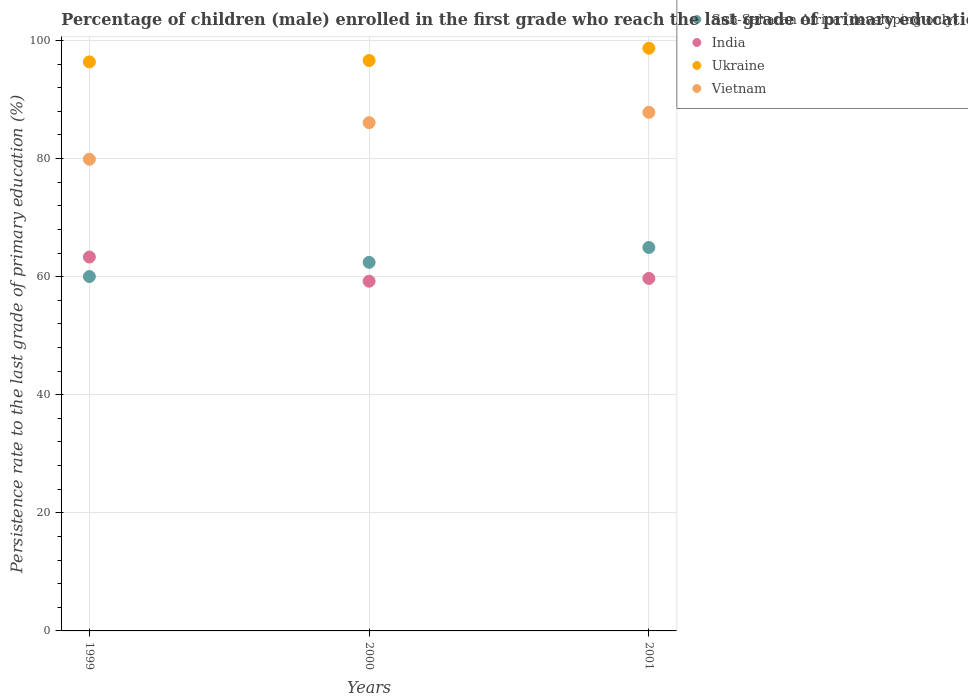How many different coloured dotlines are there?
Offer a very short reply. 4. Is the number of dotlines equal to the number of legend labels?
Your answer should be compact. Yes. What is the persistence rate of children in Ukraine in 1999?
Give a very brief answer. 96.38. Across all years, what is the maximum persistence rate of children in Ukraine?
Your answer should be very brief. 98.69. Across all years, what is the minimum persistence rate of children in Vietnam?
Your answer should be very brief. 79.89. What is the total persistence rate of children in India in the graph?
Your answer should be very brief. 182.26. What is the difference between the persistence rate of children in Sub-Saharan Africa (developing only) in 2000 and that in 2001?
Give a very brief answer. -2.52. What is the difference between the persistence rate of children in India in 1999 and the persistence rate of children in Vietnam in 2001?
Your response must be concise. -24.51. What is the average persistence rate of children in Vietnam per year?
Ensure brevity in your answer.  84.61. In the year 1999, what is the difference between the persistence rate of children in India and persistence rate of children in Vietnam?
Offer a very short reply. -16.57. In how many years, is the persistence rate of children in Vietnam greater than 80 %?
Ensure brevity in your answer.  2. What is the ratio of the persistence rate of children in Ukraine in 1999 to that in 2000?
Offer a very short reply. 1. Is the difference between the persistence rate of children in India in 1999 and 2000 greater than the difference between the persistence rate of children in Vietnam in 1999 and 2000?
Give a very brief answer. Yes. What is the difference between the highest and the second highest persistence rate of children in Sub-Saharan Africa (developing only)?
Offer a very short reply. 2.52. What is the difference between the highest and the lowest persistence rate of children in Ukraine?
Offer a very short reply. 2.32. In how many years, is the persistence rate of children in Vietnam greater than the average persistence rate of children in Vietnam taken over all years?
Ensure brevity in your answer.  2. Is the sum of the persistence rate of children in Ukraine in 1999 and 2001 greater than the maximum persistence rate of children in India across all years?
Provide a short and direct response. Yes. Is it the case that in every year, the sum of the persistence rate of children in Vietnam and persistence rate of children in India  is greater than the sum of persistence rate of children in Sub-Saharan Africa (developing only) and persistence rate of children in Ukraine?
Your answer should be very brief. No. Is the persistence rate of children in Vietnam strictly greater than the persistence rate of children in India over the years?
Offer a terse response. Yes. How many years are there in the graph?
Make the answer very short. 3. What is the difference between two consecutive major ticks on the Y-axis?
Give a very brief answer. 20. Where does the legend appear in the graph?
Offer a very short reply. Top right. How many legend labels are there?
Offer a very short reply. 4. How are the legend labels stacked?
Your answer should be very brief. Vertical. What is the title of the graph?
Your response must be concise. Percentage of children (male) enrolled in the first grade who reach the last grade of primary education. Does "Benin" appear as one of the legend labels in the graph?
Provide a short and direct response. No. What is the label or title of the Y-axis?
Ensure brevity in your answer.  Persistence rate to the last grade of primary education (%). What is the Persistence rate to the last grade of primary education (%) of Sub-Saharan Africa (developing only) in 1999?
Offer a terse response. 60.02. What is the Persistence rate to the last grade of primary education (%) in India in 1999?
Make the answer very short. 63.33. What is the Persistence rate to the last grade of primary education (%) in Ukraine in 1999?
Your answer should be compact. 96.38. What is the Persistence rate to the last grade of primary education (%) in Vietnam in 1999?
Your answer should be compact. 79.89. What is the Persistence rate to the last grade of primary education (%) of Sub-Saharan Africa (developing only) in 2000?
Your answer should be compact. 62.43. What is the Persistence rate to the last grade of primary education (%) in India in 2000?
Offer a very short reply. 59.23. What is the Persistence rate to the last grade of primary education (%) of Ukraine in 2000?
Ensure brevity in your answer.  96.61. What is the Persistence rate to the last grade of primary education (%) of Vietnam in 2000?
Provide a short and direct response. 86.09. What is the Persistence rate to the last grade of primary education (%) in Sub-Saharan Africa (developing only) in 2001?
Provide a short and direct response. 64.95. What is the Persistence rate to the last grade of primary education (%) of India in 2001?
Offer a very short reply. 59.71. What is the Persistence rate to the last grade of primary education (%) in Ukraine in 2001?
Provide a succinct answer. 98.69. What is the Persistence rate to the last grade of primary education (%) in Vietnam in 2001?
Keep it short and to the point. 87.84. Across all years, what is the maximum Persistence rate to the last grade of primary education (%) in Sub-Saharan Africa (developing only)?
Your response must be concise. 64.95. Across all years, what is the maximum Persistence rate to the last grade of primary education (%) of India?
Offer a very short reply. 63.33. Across all years, what is the maximum Persistence rate to the last grade of primary education (%) in Ukraine?
Ensure brevity in your answer.  98.69. Across all years, what is the maximum Persistence rate to the last grade of primary education (%) in Vietnam?
Keep it short and to the point. 87.84. Across all years, what is the minimum Persistence rate to the last grade of primary education (%) in Sub-Saharan Africa (developing only)?
Ensure brevity in your answer.  60.02. Across all years, what is the minimum Persistence rate to the last grade of primary education (%) of India?
Your response must be concise. 59.23. Across all years, what is the minimum Persistence rate to the last grade of primary education (%) in Ukraine?
Provide a short and direct response. 96.38. Across all years, what is the minimum Persistence rate to the last grade of primary education (%) of Vietnam?
Offer a terse response. 79.89. What is the total Persistence rate to the last grade of primary education (%) of Sub-Saharan Africa (developing only) in the graph?
Give a very brief answer. 187.4. What is the total Persistence rate to the last grade of primary education (%) in India in the graph?
Offer a terse response. 182.26. What is the total Persistence rate to the last grade of primary education (%) of Ukraine in the graph?
Keep it short and to the point. 291.69. What is the total Persistence rate to the last grade of primary education (%) in Vietnam in the graph?
Offer a terse response. 253.82. What is the difference between the Persistence rate to the last grade of primary education (%) in Sub-Saharan Africa (developing only) in 1999 and that in 2000?
Your answer should be compact. -2.4. What is the difference between the Persistence rate to the last grade of primary education (%) in India in 1999 and that in 2000?
Provide a succinct answer. 4.09. What is the difference between the Persistence rate to the last grade of primary education (%) of Ukraine in 1999 and that in 2000?
Offer a terse response. -0.24. What is the difference between the Persistence rate to the last grade of primary education (%) in Vietnam in 1999 and that in 2000?
Offer a terse response. -6.2. What is the difference between the Persistence rate to the last grade of primary education (%) of Sub-Saharan Africa (developing only) in 1999 and that in 2001?
Keep it short and to the point. -4.92. What is the difference between the Persistence rate to the last grade of primary education (%) of India in 1999 and that in 2001?
Keep it short and to the point. 3.62. What is the difference between the Persistence rate to the last grade of primary education (%) in Ukraine in 1999 and that in 2001?
Keep it short and to the point. -2.32. What is the difference between the Persistence rate to the last grade of primary education (%) of Vietnam in 1999 and that in 2001?
Keep it short and to the point. -7.94. What is the difference between the Persistence rate to the last grade of primary education (%) in Sub-Saharan Africa (developing only) in 2000 and that in 2001?
Give a very brief answer. -2.52. What is the difference between the Persistence rate to the last grade of primary education (%) of India in 2000 and that in 2001?
Ensure brevity in your answer.  -0.47. What is the difference between the Persistence rate to the last grade of primary education (%) of Ukraine in 2000 and that in 2001?
Provide a short and direct response. -2.08. What is the difference between the Persistence rate to the last grade of primary education (%) in Vietnam in 2000 and that in 2001?
Your answer should be very brief. -1.75. What is the difference between the Persistence rate to the last grade of primary education (%) in Sub-Saharan Africa (developing only) in 1999 and the Persistence rate to the last grade of primary education (%) in India in 2000?
Offer a terse response. 0.79. What is the difference between the Persistence rate to the last grade of primary education (%) in Sub-Saharan Africa (developing only) in 1999 and the Persistence rate to the last grade of primary education (%) in Ukraine in 2000?
Provide a short and direct response. -36.59. What is the difference between the Persistence rate to the last grade of primary education (%) in Sub-Saharan Africa (developing only) in 1999 and the Persistence rate to the last grade of primary education (%) in Vietnam in 2000?
Your response must be concise. -26.07. What is the difference between the Persistence rate to the last grade of primary education (%) in India in 1999 and the Persistence rate to the last grade of primary education (%) in Ukraine in 2000?
Keep it short and to the point. -33.29. What is the difference between the Persistence rate to the last grade of primary education (%) of India in 1999 and the Persistence rate to the last grade of primary education (%) of Vietnam in 2000?
Give a very brief answer. -22.77. What is the difference between the Persistence rate to the last grade of primary education (%) in Ukraine in 1999 and the Persistence rate to the last grade of primary education (%) in Vietnam in 2000?
Provide a succinct answer. 10.28. What is the difference between the Persistence rate to the last grade of primary education (%) of Sub-Saharan Africa (developing only) in 1999 and the Persistence rate to the last grade of primary education (%) of India in 2001?
Provide a short and direct response. 0.32. What is the difference between the Persistence rate to the last grade of primary education (%) in Sub-Saharan Africa (developing only) in 1999 and the Persistence rate to the last grade of primary education (%) in Ukraine in 2001?
Give a very brief answer. -38.67. What is the difference between the Persistence rate to the last grade of primary education (%) of Sub-Saharan Africa (developing only) in 1999 and the Persistence rate to the last grade of primary education (%) of Vietnam in 2001?
Provide a succinct answer. -27.81. What is the difference between the Persistence rate to the last grade of primary education (%) in India in 1999 and the Persistence rate to the last grade of primary education (%) in Ukraine in 2001?
Ensure brevity in your answer.  -35.37. What is the difference between the Persistence rate to the last grade of primary education (%) of India in 1999 and the Persistence rate to the last grade of primary education (%) of Vietnam in 2001?
Make the answer very short. -24.51. What is the difference between the Persistence rate to the last grade of primary education (%) in Ukraine in 1999 and the Persistence rate to the last grade of primary education (%) in Vietnam in 2001?
Offer a terse response. 8.54. What is the difference between the Persistence rate to the last grade of primary education (%) in Sub-Saharan Africa (developing only) in 2000 and the Persistence rate to the last grade of primary education (%) in India in 2001?
Give a very brief answer. 2.72. What is the difference between the Persistence rate to the last grade of primary education (%) in Sub-Saharan Africa (developing only) in 2000 and the Persistence rate to the last grade of primary education (%) in Ukraine in 2001?
Offer a very short reply. -36.27. What is the difference between the Persistence rate to the last grade of primary education (%) of Sub-Saharan Africa (developing only) in 2000 and the Persistence rate to the last grade of primary education (%) of Vietnam in 2001?
Ensure brevity in your answer.  -25.41. What is the difference between the Persistence rate to the last grade of primary education (%) of India in 2000 and the Persistence rate to the last grade of primary education (%) of Ukraine in 2001?
Offer a terse response. -39.46. What is the difference between the Persistence rate to the last grade of primary education (%) in India in 2000 and the Persistence rate to the last grade of primary education (%) in Vietnam in 2001?
Provide a short and direct response. -28.61. What is the difference between the Persistence rate to the last grade of primary education (%) of Ukraine in 2000 and the Persistence rate to the last grade of primary education (%) of Vietnam in 2001?
Keep it short and to the point. 8.78. What is the average Persistence rate to the last grade of primary education (%) in Sub-Saharan Africa (developing only) per year?
Offer a very short reply. 62.47. What is the average Persistence rate to the last grade of primary education (%) in India per year?
Provide a succinct answer. 60.75. What is the average Persistence rate to the last grade of primary education (%) of Ukraine per year?
Provide a succinct answer. 97.23. What is the average Persistence rate to the last grade of primary education (%) of Vietnam per year?
Offer a very short reply. 84.61. In the year 1999, what is the difference between the Persistence rate to the last grade of primary education (%) of Sub-Saharan Africa (developing only) and Persistence rate to the last grade of primary education (%) of India?
Make the answer very short. -3.3. In the year 1999, what is the difference between the Persistence rate to the last grade of primary education (%) of Sub-Saharan Africa (developing only) and Persistence rate to the last grade of primary education (%) of Ukraine?
Offer a terse response. -36.35. In the year 1999, what is the difference between the Persistence rate to the last grade of primary education (%) of Sub-Saharan Africa (developing only) and Persistence rate to the last grade of primary education (%) of Vietnam?
Keep it short and to the point. -19.87. In the year 1999, what is the difference between the Persistence rate to the last grade of primary education (%) of India and Persistence rate to the last grade of primary education (%) of Ukraine?
Ensure brevity in your answer.  -33.05. In the year 1999, what is the difference between the Persistence rate to the last grade of primary education (%) of India and Persistence rate to the last grade of primary education (%) of Vietnam?
Keep it short and to the point. -16.57. In the year 1999, what is the difference between the Persistence rate to the last grade of primary education (%) in Ukraine and Persistence rate to the last grade of primary education (%) in Vietnam?
Offer a terse response. 16.48. In the year 2000, what is the difference between the Persistence rate to the last grade of primary education (%) in Sub-Saharan Africa (developing only) and Persistence rate to the last grade of primary education (%) in India?
Provide a short and direct response. 3.2. In the year 2000, what is the difference between the Persistence rate to the last grade of primary education (%) of Sub-Saharan Africa (developing only) and Persistence rate to the last grade of primary education (%) of Ukraine?
Your answer should be compact. -34.19. In the year 2000, what is the difference between the Persistence rate to the last grade of primary education (%) of Sub-Saharan Africa (developing only) and Persistence rate to the last grade of primary education (%) of Vietnam?
Make the answer very short. -23.66. In the year 2000, what is the difference between the Persistence rate to the last grade of primary education (%) of India and Persistence rate to the last grade of primary education (%) of Ukraine?
Ensure brevity in your answer.  -37.38. In the year 2000, what is the difference between the Persistence rate to the last grade of primary education (%) of India and Persistence rate to the last grade of primary education (%) of Vietnam?
Your answer should be compact. -26.86. In the year 2000, what is the difference between the Persistence rate to the last grade of primary education (%) in Ukraine and Persistence rate to the last grade of primary education (%) in Vietnam?
Provide a succinct answer. 10.52. In the year 2001, what is the difference between the Persistence rate to the last grade of primary education (%) of Sub-Saharan Africa (developing only) and Persistence rate to the last grade of primary education (%) of India?
Your answer should be compact. 5.24. In the year 2001, what is the difference between the Persistence rate to the last grade of primary education (%) of Sub-Saharan Africa (developing only) and Persistence rate to the last grade of primary education (%) of Ukraine?
Provide a short and direct response. -33.75. In the year 2001, what is the difference between the Persistence rate to the last grade of primary education (%) of Sub-Saharan Africa (developing only) and Persistence rate to the last grade of primary education (%) of Vietnam?
Provide a short and direct response. -22.89. In the year 2001, what is the difference between the Persistence rate to the last grade of primary education (%) of India and Persistence rate to the last grade of primary education (%) of Ukraine?
Your answer should be compact. -38.99. In the year 2001, what is the difference between the Persistence rate to the last grade of primary education (%) of India and Persistence rate to the last grade of primary education (%) of Vietnam?
Give a very brief answer. -28.13. In the year 2001, what is the difference between the Persistence rate to the last grade of primary education (%) of Ukraine and Persistence rate to the last grade of primary education (%) of Vietnam?
Ensure brevity in your answer.  10.86. What is the ratio of the Persistence rate to the last grade of primary education (%) in Sub-Saharan Africa (developing only) in 1999 to that in 2000?
Offer a very short reply. 0.96. What is the ratio of the Persistence rate to the last grade of primary education (%) in India in 1999 to that in 2000?
Give a very brief answer. 1.07. What is the ratio of the Persistence rate to the last grade of primary education (%) of Ukraine in 1999 to that in 2000?
Make the answer very short. 1. What is the ratio of the Persistence rate to the last grade of primary education (%) of Vietnam in 1999 to that in 2000?
Keep it short and to the point. 0.93. What is the ratio of the Persistence rate to the last grade of primary education (%) of Sub-Saharan Africa (developing only) in 1999 to that in 2001?
Your answer should be very brief. 0.92. What is the ratio of the Persistence rate to the last grade of primary education (%) in India in 1999 to that in 2001?
Make the answer very short. 1.06. What is the ratio of the Persistence rate to the last grade of primary education (%) in Ukraine in 1999 to that in 2001?
Give a very brief answer. 0.98. What is the ratio of the Persistence rate to the last grade of primary education (%) in Vietnam in 1999 to that in 2001?
Your answer should be compact. 0.91. What is the ratio of the Persistence rate to the last grade of primary education (%) of Sub-Saharan Africa (developing only) in 2000 to that in 2001?
Ensure brevity in your answer.  0.96. What is the ratio of the Persistence rate to the last grade of primary education (%) in India in 2000 to that in 2001?
Keep it short and to the point. 0.99. What is the ratio of the Persistence rate to the last grade of primary education (%) of Ukraine in 2000 to that in 2001?
Your answer should be very brief. 0.98. What is the ratio of the Persistence rate to the last grade of primary education (%) of Vietnam in 2000 to that in 2001?
Ensure brevity in your answer.  0.98. What is the difference between the highest and the second highest Persistence rate to the last grade of primary education (%) of Sub-Saharan Africa (developing only)?
Keep it short and to the point. 2.52. What is the difference between the highest and the second highest Persistence rate to the last grade of primary education (%) in India?
Give a very brief answer. 3.62. What is the difference between the highest and the second highest Persistence rate to the last grade of primary education (%) in Ukraine?
Your answer should be compact. 2.08. What is the difference between the highest and the second highest Persistence rate to the last grade of primary education (%) of Vietnam?
Give a very brief answer. 1.75. What is the difference between the highest and the lowest Persistence rate to the last grade of primary education (%) in Sub-Saharan Africa (developing only)?
Your answer should be very brief. 4.92. What is the difference between the highest and the lowest Persistence rate to the last grade of primary education (%) of India?
Your response must be concise. 4.09. What is the difference between the highest and the lowest Persistence rate to the last grade of primary education (%) of Ukraine?
Keep it short and to the point. 2.32. What is the difference between the highest and the lowest Persistence rate to the last grade of primary education (%) of Vietnam?
Offer a very short reply. 7.94. 